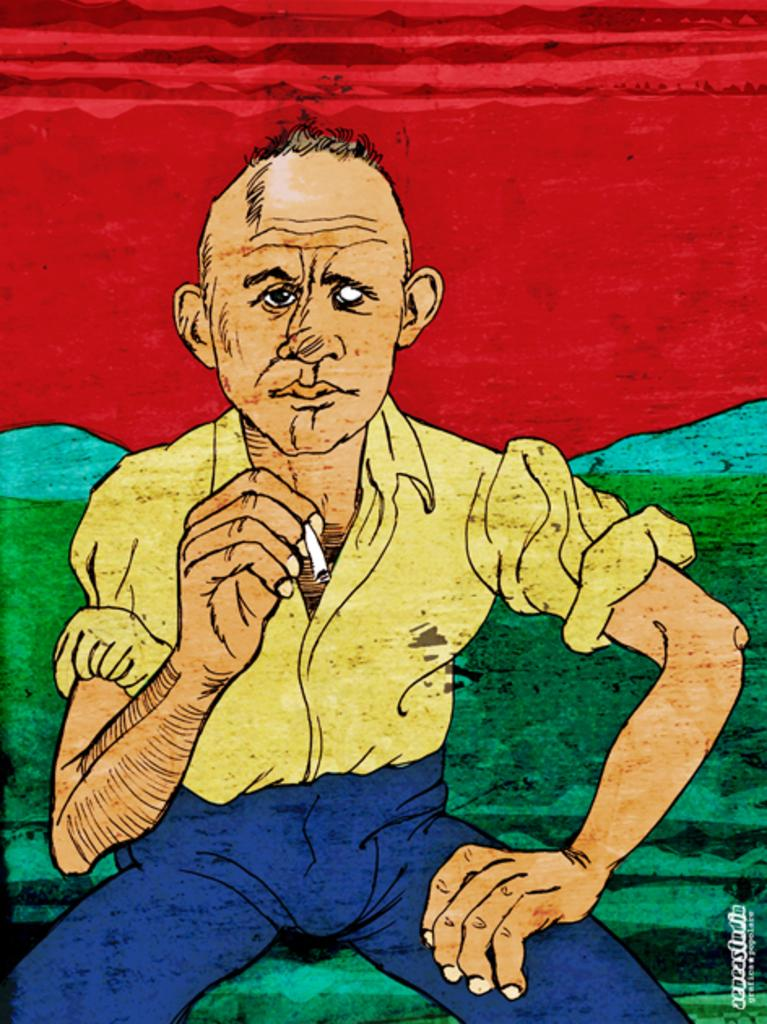Who is present in the image? There is a man in the image. What is the man doing in the image? The man is sitting. What is the man holding in the image? The man is holding a cigarette. What can be seen in the distance in the image? There are hills visible in the background of the image. What type of haircut does the snake have in the image? There is no snake present in the image, and therefore no haircut can be observed. What color is the brick that the man is leaning against in the image? There is no brick visible in the image; the man is sitting on a surface that is not described in the provided facts. 